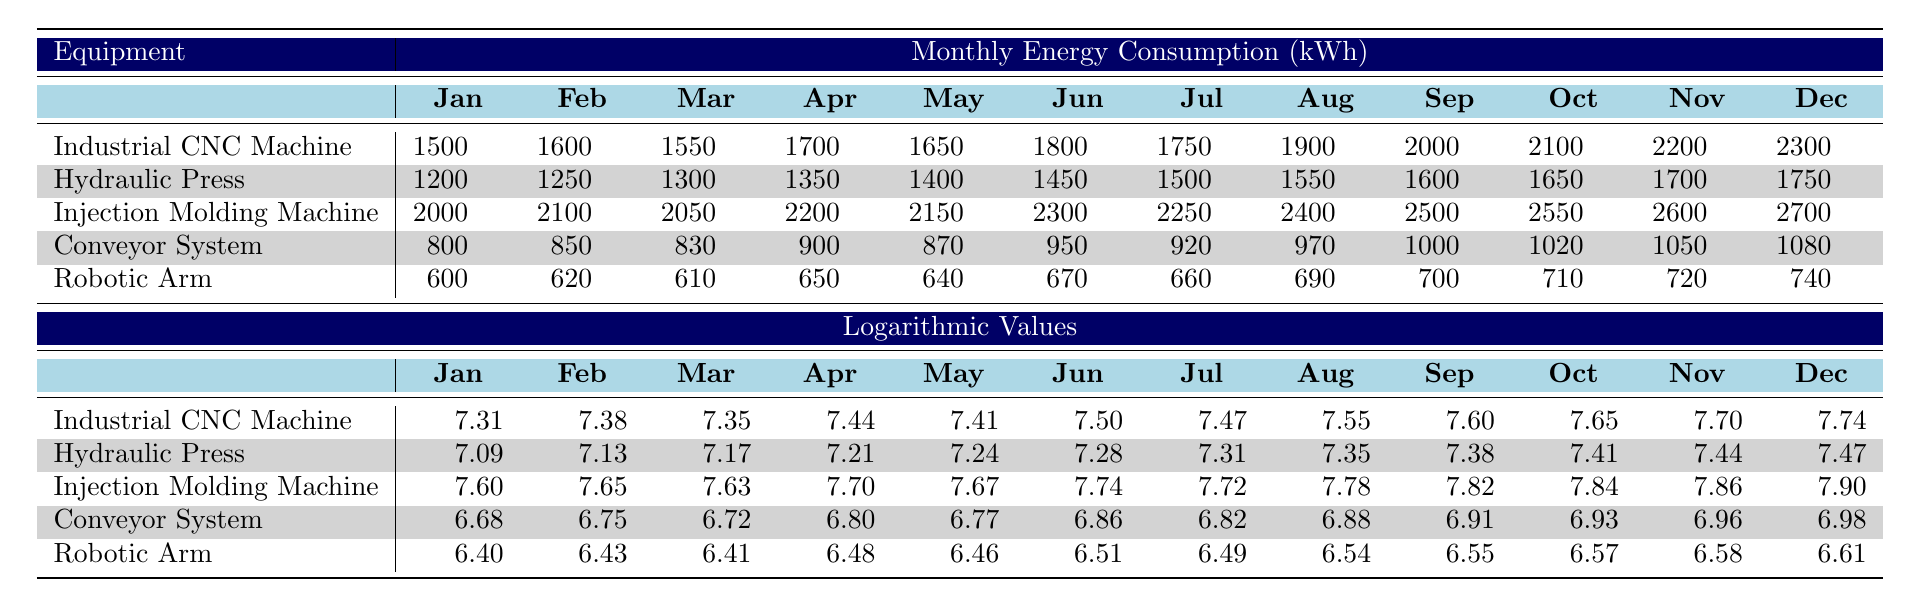What is the highest monthly energy consumption recorded for the Injection Molding Machine? Looking at the monthly consumption for the Injection Molding Machine, the values are 2000, 2100, 2050, 2200, 2150, 2300, 2250, 2400, 2500, 2550, 2600, and 2700. The highest value among these is 2700 kWh.
Answer: 2700 kWh What is the average monthly energy consumption for the Hydraulic Press over the year? The monthly consumptions for the Hydraulic Press are 1200, 1250, 1300, 1350, 1400, 1450, 1500, 1550, 1600, 1650, 1700, and 1750. The sum of these values is 18650 kWh. There are 12 months, so the average is 18650/12 = 1554.17 kWh.
Answer: 1554.17 kWh Did the energy consumption of the Robotic Arm ever exceed 700 kWh in any month? Reviewing the monthly values for the Robotic Arm, which are 600, 620, 610, 650, 640, 670, 660, 690, 700, 710, 720, and 740, I can see that it reached and exceeded 700 kWh starting from October with a value of 710 kWh.
Answer: Yes Which equipment had the lowest energy consumption in January? In January, the energy consumptions were 1500 kWh for the Industrial CNC Machine, 1200 kWh for the Hydraulic Press, 2000 kWh for the Injection Molding Machine, 800 kWh for the Conveyor System, and 600 kWh for the Robotic Arm. The lowest value is 600 kWh from the Robotic Arm.
Answer: Robotic Arm What was the change in energy consumption of the Industrial CNC Machine from January to December? The consumption in January for the Industrial CNC Machine was 1500 kWh, and in December it was 2300 kWh. The change is calculated as 2300 - 1500 = 800 kWh increase over the year.
Answer: 800 kWh increase What is the total annual energy consumption of the Conveyor System? The monthly values for the Conveyor System are 800, 850, 830, 900, 870, 950, 920, 970, 1000, 1020, 1050, and 1080. The total is calculated as 800 + 850 + 830 + 900 + 870 + 950 + 920 + 970 + 1000 + 1020 + 1050 + 1080 = 11470 kWh for the year.
Answer: 11470 kWh Which equipment shows a consistent increase in energy consumption over the months? Analyzing the monthly values, the Industrial CNC Machine and Injection Molding Machine both show a consistent increase each month. The values for the Industrial CNC Machine grow from 1500 to 2300, and for the Injection Molding Machine from 2000 to 2700 without any declines.
Answer: Industrial CNC Machine and Injection Molding Machine Is it true that the energy consumption of the Hydraulic Press is consistently less than that of the Industrial CNC Machine? Comparing the monthly values, the Hydraulic Press starts at 1200 kWh and increases to 1750 kWh, while the Industrial CNC Machine starts at 1500 kWh and increases to 2300 kWh. Hydraulic Press values are always lower than corresponding values of the Industrial CNC Machine. The statement is true.
Answer: Yes 